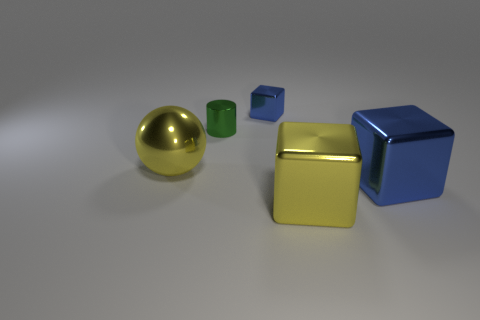What number of rubber things are either balls or tiny cyan things? In the image, there is one rubber object which is a ball, and there are no tiny cyan things present. Therefore, the total number of rubber things that are either balls or tiny cyan things is one. 